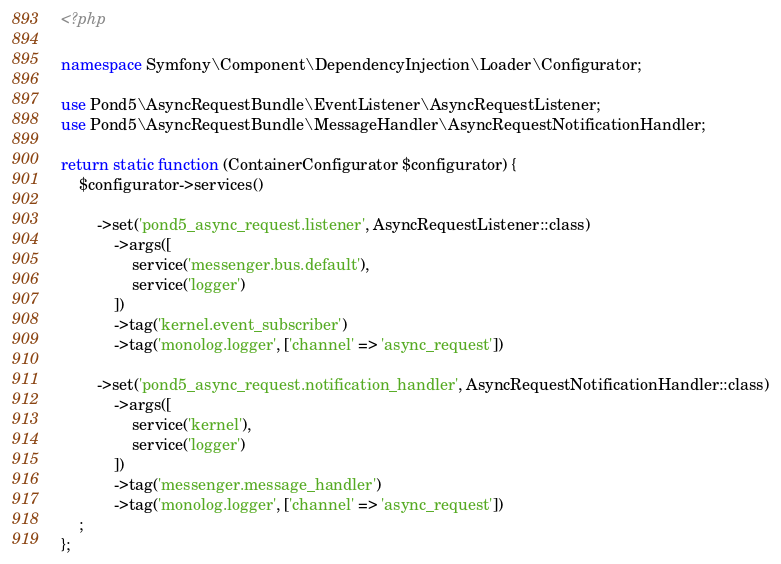Convert code to text. <code><loc_0><loc_0><loc_500><loc_500><_PHP_><?php

namespace Symfony\Component\DependencyInjection\Loader\Configurator;

use Pond5\AsyncRequestBundle\EventListener\AsyncRequestListener;
use Pond5\AsyncRequestBundle\MessageHandler\AsyncRequestNotificationHandler;

return static function (ContainerConfigurator $configurator) {
    $configurator->services()

        ->set('pond5_async_request.listener', AsyncRequestListener::class)
            ->args([
                service('messenger.bus.default'),
                service('logger')
            ])
            ->tag('kernel.event_subscriber')
            ->tag('monolog.logger', ['channel' => 'async_request'])

        ->set('pond5_async_request.notification_handler', AsyncRequestNotificationHandler::class)
            ->args([
                service('kernel'),
                service('logger')
            ])
            ->tag('messenger.message_handler')
            ->tag('monolog.logger', ['channel' => 'async_request'])
    ;
};
</code> 